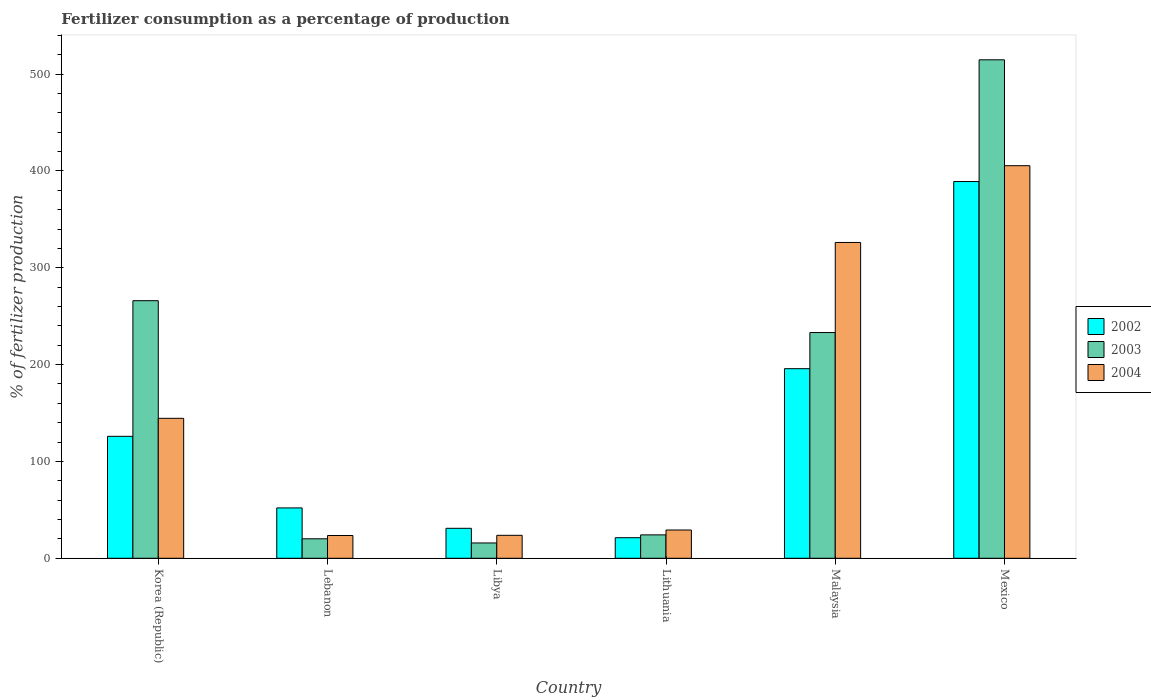How many groups of bars are there?
Provide a succinct answer. 6. Are the number of bars per tick equal to the number of legend labels?
Provide a succinct answer. Yes. Are the number of bars on each tick of the X-axis equal?
Ensure brevity in your answer.  Yes. How many bars are there on the 6th tick from the right?
Offer a terse response. 3. What is the label of the 2nd group of bars from the left?
Make the answer very short. Lebanon. What is the percentage of fertilizers consumed in 2002 in Malaysia?
Keep it short and to the point. 195.8. Across all countries, what is the maximum percentage of fertilizers consumed in 2002?
Provide a succinct answer. 389.08. Across all countries, what is the minimum percentage of fertilizers consumed in 2003?
Your answer should be compact. 15.82. In which country was the percentage of fertilizers consumed in 2004 maximum?
Your answer should be compact. Mexico. In which country was the percentage of fertilizers consumed in 2003 minimum?
Your response must be concise. Libya. What is the total percentage of fertilizers consumed in 2004 in the graph?
Your answer should be compact. 952.53. What is the difference between the percentage of fertilizers consumed in 2004 in Libya and that in Mexico?
Offer a terse response. -381.73. What is the difference between the percentage of fertilizers consumed in 2002 in Lebanon and the percentage of fertilizers consumed in 2003 in Lithuania?
Your answer should be very brief. 27.84. What is the average percentage of fertilizers consumed in 2004 per country?
Offer a very short reply. 158.75. What is the difference between the percentage of fertilizers consumed of/in 2003 and percentage of fertilizers consumed of/in 2004 in Korea (Republic)?
Keep it short and to the point. 121.49. In how many countries, is the percentage of fertilizers consumed in 2004 greater than 80 %?
Keep it short and to the point. 3. What is the ratio of the percentage of fertilizers consumed in 2002 in Libya to that in Mexico?
Your answer should be compact. 0.08. Is the percentage of fertilizers consumed in 2004 in Lebanon less than that in Lithuania?
Your answer should be compact. Yes. What is the difference between the highest and the second highest percentage of fertilizers consumed in 2002?
Keep it short and to the point. -69.85. What is the difference between the highest and the lowest percentage of fertilizers consumed in 2004?
Offer a terse response. 381.93. In how many countries, is the percentage of fertilizers consumed in 2003 greater than the average percentage of fertilizers consumed in 2003 taken over all countries?
Your answer should be very brief. 3. Is the sum of the percentage of fertilizers consumed in 2003 in Libya and Lithuania greater than the maximum percentage of fertilizers consumed in 2004 across all countries?
Keep it short and to the point. No. What does the 3rd bar from the right in Lebanon represents?
Provide a succinct answer. 2002. How many bars are there?
Keep it short and to the point. 18. Are all the bars in the graph horizontal?
Your response must be concise. No. What is the difference between two consecutive major ticks on the Y-axis?
Ensure brevity in your answer.  100. Are the values on the major ticks of Y-axis written in scientific E-notation?
Your response must be concise. No. Does the graph contain any zero values?
Your answer should be compact. No. Does the graph contain grids?
Provide a succinct answer. No. How many legend labels are there?
Your response must be concise. 3. What is the title of the graph?
Make the answer very short. Fertilizer consumption as a percentage of production. Does "1970" appear as one of the legend labels in the graph?
Your answer should be very brief. No. What is the label or title of the X-axis?
Ensure brevity in your answer.  Country. What is the label or title of the Y-axis?
Your response must be concise. % of fertilizer production. What is the % of fertilizer production of 2002 in Korea (Republic)?
Make the answer very short. 125.95. What is the % of fertilizer production of 2003 in Korea (Republic)?
Offer a very short reply. 266.02. What is the % of fertilizer production in 2004 in Korea (Republic)?
Your response must be concise. 144.54. What is the % of fertilizer production in 2003 in Lebanon?
Give a very brief answer. 20.12. What is the % of fertilizer production of 2004 in Lebanon?
Provide a short and direct response. 23.51. What is the % of fertilizer production in 2002 in Libya?
Make the answer very short. 30.95. What is the % of fertilizer production in 2003 in Libya?
Provide a succinct answer. 15.82. What is the % of fertilizer production in 2004 in Libya?
Give a very brief answer. 23.71. What is the % of fertilizer production in 2002 in Lithuania?
Provide a short and direct response. 21.23. What is the % of fertilizer production of 2003 in Lithuania?
Your response must be concise. 24.16. What is the % of fertilizer production of 2004 in Lithuania?
Your answer should be very brief. 29.18. What is the % of fertilizer production in 2002 in Malaysia?
Give a very brief answer. 195.8. What is the % of fertilizer production in 2003 in Malaysia?
Provide a succinct answer. 233.12. What is the % of fertilizer production in 2004 in Malaysia?
Keep it short and to the point. 326.16. What is the % of fertilizer production in 2002 in Mexico?
Keep it short and to the point. 389.08. What is the % of fertilizer production in 2003 in Mexico?
Keep it short and to the point. 514.81. What is the % of fertilizer production in 2004 in Mexico?
Your response must be concise. 405.44. Across all countries, what is the maximum % of fertilizer production in 2002?
Make the answer very short. 389.08. Across all countries, what is the maximum % of fertilizer production of 2003?
Provide a succinct answer. 514.81. Across all countries, what is the maximum % of fertilizer production of 2004?
Keep it short and to the point. 405.44. Across all countries, what is the minimum % of fertilizer production of 2002?
Provide a succinct answer. 21.23. Across all countries, what is the minimum % of fertilizer production of 2003?
Make the answer very short. 15.82. Across all countries, what is the minimum % of fertilizer production in 2004?
Provide a short and direct response. 23.51. What is the total % of fertilizer production in 2002 in the graph?
Make the answer very short. 815.02. What is the total % of fertilizer production in 2003 in the graph?
Make the answer very short. 1074.04. What is the total % of fertilizer production in 2004 in the graph?
Offer a very short reply. 952.53. What is the difference between the % of fertilizer production in 2002 in Korea (Republic) and that in Lebanon?
Ensure brevity in your answer.  73.95. What is the difference between the % of fertilizer production of 2003 in Korea (Republic) and that in Lebanon?
Your answer should be very brief. 245.91. What is the difference between the % of fertilizer production of 2004 in Korea (Republic) and that in Lebanon?
Your answer should be compact. 121.03. What is the difference between the % of fertilizer production of 2002 in Korea (Republic) and that in Libya?
Offer a very short reply. 95. What is the difference between the % of fertilizer production of 2003 in Korea (Republic) and that in Libya?
Give a very brief answer. 250.21. What is the difference between the % of fertilizer production in 2004 in Korea (Republic) and that in Libya?
Your answer should be very brief. 120.83. What is the difference between the % of fertilizer production in 2002 in Korea (Republic) and that in Lithuania?
Ensure brevity in your answer.  104.72. What is the difference between the % of fertilizer production in 2003 in Korea (Republic) and that in Lithuania?
Give a very brief answer. 241.86. What is the difference between the % of fertilizer production in 2004 in Korea (Republic) and that in Lithuania?
Provide a succinct answer. 115.36. What is the difference between the % of fertilizer production in 2002 in Korea (Republic) and that in Malaysia?
Offer a very short reply. -69.85. What is the difference between the % of fertilizer production of 2003 in Korea (Republic) and that in Malaysia?
Ensure brevity in your answer.  32.9. What is the difference between the % of fertilizer production of 2004 in Korea (Republic) and that in Malaysia?
Keep it short and to the point. -181.62. What is the difference between the % of fertilizer production of 2002 in Korea (Republic) and that in Mexico?
Keep it short and to the point. -263.13. What is the difference between the % of fertilizer production of 2003 in Korea (Republic) and that in Mexico?
Make the answer very short. -248.78. What is the difference between the % of fertilizer production in 2004 in Korea (Republic) and that in Mexico?
Offer a very short reply. -260.9. What is the difference between the % of fertilizer production in 2002 in Lebanon and that in Libya?
Your answer should be compact. 21.05. What is the difference between the % of fertilizer production of 2003 in Lebanon and that in Libya?
Offer a terse response. 4.3. What is the difference between the % of fertilizer production in 2004 in Lebanon and that in Libya?
Offer a terse response. -0.2. What is the difference between the % of fertilizer production in 2002 in Lebanon and that in Lithuania?
Offer a very short reply. 30.77. What is the difference between the % of fertilizer production in 2003 in Lebanon and that in Lithuania?
Provide a succinct answer. -4.05. What is the difference between the % of fertilizer production in 2004 in Lebanon and that in Lithuania?
Offer a very short reply. -5.67. What is the difference between the % of fertilizer production of 2002 in Lebanon and that in Malaysia?
Offer a terse response. -143.8. What is the difference between the % of fertilizer production of 2003 in Lebanon and that in Malaysia?
Make the answer very short. -213. What is the difference between the % of fertilizer production in 2004 in Lebanon and that in Malaysia?
Provide a succinct answer. -302.65. What is the difference between the % of fertilizer production in 2002 in Lebanon and that in Mexico?
Offer a terse response. -337.08. What is the difference between the % of fertilizer production of 2003 in Lebanon and that in Mexico?
Keep it short and to the point. -494.69. What is the difference between the % of fertilizer production in 2004 in Lebanon and that in Mexico?
Offer a terse response. -381.93. What is the difference between the % of fertilizer production of 2002 in Libya and that in Lithuania?
Offer a very short reply. 9.72. What is the difference between the % of fertilizer production in 2003 in Libya and that in Lithuania?
Your answer should be very brief. -8.35. What is the difference between the % of fertilizer production in 2004 in Libya and that in Lithuania?
Give a very brief answer. -5.48. What is the difference between the % of fertilizer production in 2002 in Libya and that in Malaysia?
Your response must be concise. -164.85. What is the difference between the % of fertilizer production in 2003 in Libya and that in Malaysia?
Ensure brevity in your answer.  -217.3. What is the difference between the % of fertilizer production of 2004 in Libya and that in Malaysia?
Ensure brevity in your answer.  -302.45. What is the difference between the % of fertilizer production of 2002 in Libya and that in Mexico?
Ensure brevity in your answer.  -358.13. What is the difference between the % of fertilizer production of 2003 in Libya and that in Mexico?
Your answer should be compact. -498.99. What is the difference between the % of fertilizer production in 2004 in Libya and that in Mexico?
Your response must be concise. -381.73. What is the difference between the % of fertilizer production of 2002 in Lithuania and that in Malaysia?
Keep it short and to the point. -174.57. What is the difference between the % of fertilizer production of 2003 in Lithuania and that in Malaysia?
Your answer should be very brief. -208.96. What is the difference between the % of fertilizer production in 2004 in Lithuania and that in Malaysia?
Your answer should be compact. -296.98. What is the difference between the % of fertilizer production in 2002 in Lithuania and that in Mexico?
Offer a very short reply. -367.85. What is the difference between the % of fertilizer production in 2003 in Lithuania and that in Mexico?
Keep it short and to the point. -490.64. What is the difference between the % of fertilizer production of 2004 in Lithuania and that in Mexico?
Provide a short and direct response. -376.26. What is the difference between the % of fertilizer production in 2002 in Malaysia and that in Mexico?
Ensure brevity in your answer.  -193.28. What is the difference between the % of fertilizer production in 2003 in Malaysia and that in Mexico?
Make the answer very short. -281.69. What is the difference between the % of fertilizer production of 2004 in Malaysia and that in Mexico?
Provide a short and direct response. -79.28. What is the difference between the % of fertilizer production of 2002 in Korea (Republic) and the % of fertilizer production of 2003 in Lebanon?
Provide a succinct answer. 105.84. What is the difference between the % of fertilizer production in 2002 in Korea (Republic) and the % of fertilizer production in 2004 in Lebanon?
Offer a terse response. 102.44. What is the difference between the % of fertilizer production in 2003 in Korea (Republic) and the % of fertilizer production in 2004 in Lebanon?
Provide a succinct answer. 242.52. What is the difference between the % of fertilizer production of 2002 in Korea (Republic) and the % of fertilizer production of 2003 in Libya?
Provide a succinct answer. 110.13. What is the difference between the % of fertilizer production in 2002 in Korea (Republic) and the % of fertilizer production in 2004 in Libya?
Your answer should be compact. 102.25. What is the difference between the % of fertilizer production of 2003 in Korea (Republic) and the % of fertilizer production of 2004 in Libya?
Keep it short and to the point. 242.32. What is the difference between the % of fertilizer production of 2002 in Korea (Republic) and the % of fertilizer production of 2003 in Lithuania?
Your response must be concise. 101.79. What is the difference between the % of fertilizer production of 2002 in Korea (Republic) and the % of fertilizer production of 2004 in Lithuania?
Offer a terse response. 96.77. What is the difference between the % of fertilizer production in 2003 in Korea (Republic) and the % of fertilizer production in 2004 in Lithuania?
Give a very brief answer. 236.84. What is the difference between the % of fertilizer production of 2002 in Korea (Republic) and the % of fertilizer production of 2003 in Malaysia?
Provide a short and direct response. -107.17. What is the difference between the % of fertilizer production of 2002 in Korea (Republic) and the % of fertilizer production of 2004 in Malaysia?
Make the answer very short. -200.21. What is the difference between the % of fertilizer production in 2003 in Korea (Republic) and the % of fertilizer production in 2004 in Malaysia?
Your response must be concise. -60.14. What is the difference between the % of fertilizer production of 2002 in Korea (Republic) and the % of fertilizer production of 2003 in Mexico?
Your answer should be compact. -388.85. What is the difference between the % of fertilizer production of 2002 in Korea (Republic) and the % of fertilizer production of 2004 in Mexico?
Offer a terse response. -279.49. What is the difference between the % of fertilizer production in 2003 in Korea (Republic) and the % of fertilizer production in 2004 in Mexico?
Offer a terse response. -139.42. What is the difference between the % of fertilizer production in 2002 in Lebanon and the % of fertilizer production in 2003 in Libya?
Your answer should be very brief. 36.18. What is the difference between the % of fertilizer production of 2002 in Lebanon and the % of fertilizer production of 2004 in Libya?
Offer a terse response. 28.29. What is the difference between the % of fertilizer production of 2003 in Lebanon and the % of fertilizer production of 2004 in Libya?
Offer a very short reply. -3.59. What is the difference between the % of fertilizer production of 2002 in Lebanon and the % of fertilizer production of 2003 in Lithuania?
Your answer should be very brief. 27.84. What is the difference between the % of fertilizer production in 2002 in Lebanon and the % of fertilizer production in 2004 in Lithuania?
Offer a very short reply. 22.82. What is the difference between the % of fertilizer production in 2003 in Lebanon and the % of fertilizer production in 2004 in Lithuania?
Provide a short and direct response. -9.07. What is the difference between the % of fertilizer production of 2002 in Lebanon and the % of fertilizer production of 2003 in Malaysia?
Provide a succinct answer. -181.12. What is the difference between the % of fertilizer production in 2002 in Lebanon and the % of fertilizer production in 2004 in Malaysia?
Offer a very short reply. -274.16. What is the difference between the % of fertilizer production of 2003 in Lebanon and the % of fertilizer production of 2004 in Malaysia?
Offer a very short reply. -306.04. What is the difference between the % of fertilizer production of 2002 in Lebanon and the % of fertilizer production of 2003 in Mexico?
Provide a succinct answer. -462.81. What is the difference between the % of fertilizer production in 2002 in Lebanon and the % of fertilizer production in 2004 in Mexico?
Your answer should be very brief. -353.44. What is the difference between the % of fertilizer production in 2003 in Lebanon and the % of fertilizer production in 2004 in Mexico?
Your response must be concise. -385.32. What is the difference between the % of fertilizer production in 2002 in Libya and the % of fertilizer production in 2003 in Lithuania?
Provide a succinct answer. 6.79. What is the difference between the % of fertilizer production in 2002 in Libya and the % of fertilizer production in 2004 in Lithuania?
Ensure brevity in your answer.  1.77. What is the difference between the % of fertilizer production in 2003 in Libya and the % of fertilizer production in 2004 in Lithuania?
Your answer should be very brief. -13.37. What is the difference between the % of fertilizer production of 2002 in Libya and the % of fertilizer production of 2003 in Malaysia?
Offer a very short reply. -202.17. What is the difference between the % of fertilizer production of 2002 in Libya and the % of fertilizer production of 2004 in Malaysia?
Your response must be concise. -295.2. What is the difference between the % of fertilizer production of 2003 in Libya and the % of fertilizer production of 2004 in Malaysia?
Make the answer very short. -310.34. What is the difference between the % of fertilizer production of 2002 in Libya and the % of fertilizer production of 2003 in Mexico?
Provide a short and direct response. -483.85. What is the difference between the % of fertilizer production of 2002 in Libya and the % of fertilizer production of 2004 in Mexico?
Give a very brief answer. -374.48. What is the difference between the % of fertilizer production in 2003 in Libya and the % of fertilizer production in 2004 in Mexico?
Give a very brief answer. -389.62. What is the difference between the % of fertilizer production of 2002 in Lithuania and the % of fertilizer production of 2003 in Malaysia?
Your answer should be compact. -211.89. What is the difference between the % of fertilizer production in 2002 in Lithuania and the % of fertilizer production in 2004 in Malaysia?
Give a very brief answer. -304.93. What is the difference between the % of fertilizer production of 2003 in Lithuania and the % of fertilizer production of 2004 in Malaysia?
Keep it short and to the point. -302. What is the difference between the % of fertilizer production in 2002 in Lithuania and the % of fertilizer production in 2003 in Mexico?
Your answer should be compact. -493.57. What is the difference between the % of fertilizer production in 2002 in Lithuania and the % of fertilizer production in 2004 in Mexico?
Your response must be concise. -384.21. What is the difference between the % of fertilizer production in 2003 in Lithuania and the % of fertilizer production in 2004 in Mexico?
Your answer should be very brief. -381.28. What is the difference between the % of fertilizer production of 2002 in Malaysia and the % of fertilizer production of 2003 in Mexico?
Give a very brief answer. -319. What is the difference between the % of fertilizer production of 2002 in Malaysia and the % of fertilizer production of 2004 in Mexico?
Keep it short and to the point. -209.64. What is the difference between the % of fertilizer production of 2003 in Malaysia and the % of fertilizer production of 2004 in Mexico?
Your answer should be compact. -172.32. What is the average % of fertilizer production of 2002 per country?
Ensure brevity in your answer.  135.84. What is the average % of fertilizer production in 2003 per country?
Ensure brevity in your answer.  179.01. What is the average % of fertilizer production in 2004 per country?
Provide a short and direct response. 158.75. What is the difference between the % of fertilizer production in 2002 and % of fertilizer production in 2003 in Korea (Republic)?
Make the answer very short. -140.07. What is the difference between the % of fertilizer production of 2002 and % of fertilizer production of 2004 in Korea (Republic)?
Your answer should be compact. -18.59. What is the difference between the % of fertilizer production of 2003 and % of fertilizer production of 2004 in Korea (Republic)?
Offer a very short reply. 121.49. What is the difference between the % of fertilizer production of 2002 and % of fertilizer production of 2003 in Lebanon?
Offer a terse response. 31.88. What is the difference between the % of fertilizer production of 2002 and % of fertilizer production of 2004 in Lebanon?
Provide a succinct answer. 28.49. What is the difference between the % of fertilizer production of 2003 and % of fertilizer production of 2004 in Lebanon?
Offer a very short reply. -3.39. What is the difference between the % of fertilizer production in 2002 and % of fertilizer production in 2003 in Libya?
Give a very brief answer. 15.14. What is the difference between the % of fertilizer production of 2002 and % of fertilizer production of 2004 in Libya?
Keep it short and to the point. 7.25. What is the difference between the % of fertilizer production of 2003 and % of fertilizer production of 2004 in Libya?
Provide a short and direct response. -7.89. What is the difference between the % of fertilizer production of 2002 and % of fertilizer production of 2003 in Lithuania?
Ensure brevity in your answer.  -2.93. What is the difference between the % of fertilizer production in 2002 and % of fertilizer production in 2004 in Lithuania?
Your response must be concise. -7.95. What is the difference between the % of fertilizer production in 2003 and % of fertilizer production in 2004 in Lithuania?
Keep it short and to the point. -5.02. What is the difference between the % of fertilizer production of 2002 and % of fertilizer production of 2003 in Malaysia?
Keep it short and to the point. -37.32. What is the difference between the % of fertilizer production in 2002 and % of fertilizer production in 2004 in Malaysia?
Make the answer very short. -130.36. What is the difference between the % of fertilizer production in 2003 and % of fertilizer production in 2004 in Malaysia?
Provide a short and direct response. -93.04. What is the difference between the % of fertilizer production of 2002 and % of fertilizer production of 2003 in Mexico?
Make the answer very short. -125.73. What is the difference between the % of fertilizer production in 2002 and % of fertilizer production in 2004 in Mexico?
Give a very brief answer. -16.36. What is the difference between the % of fertilizer production in 2003 and % of fertilizer production in 2004 in Mexico?
Your answer should be very brief. 109.37. What is the ratio of the % of fertilizer production of 2002 in Korea (Republic) to that in Lebanon?
Keep it short and to the point. 2.42. What is the ratio of the % of fertilizer production of 2003 in Korea (Republic) to that in Lebanon?
Keep it short and to the point. 13.22. What is the ratio of the % of fertilizer production of 2004 in Korea (Republic) to that in Lebanon?
Give a very brief answer. 6.15. What is the ratio of the % of fertilizer production of 2002 in Korea (Republic) to that in Libya?
Ensure brevity in your answer.  4.07. What is the ratio of the % of fertilizer production of 2003 in Korea (Republic) to that in Libya?
Ensure brevity in your answer.  16.82. What is the ratio of the % of fertilizer production in 2004 in Korea (Republic) to that in Libya?
Your answer should be very brief. 6.1. What is the ratio of the % of fertilizer production of 2002 in Korea (Republic) to that in Lithuania?
Give a very brief answer. 5.93. What is the ratio of the % of fertilizer production of 2003 in Korea (Republic) to that in Lithuania?
Your answer should be compact. 11.01. What is the ratio of the % of fertilizer production in 2004 in Korea (Republic) to that in Lithuania?
Provide a short and direct response. 4.95. What is the ratio of the % of fertilizer production of 2002 in Korea (Republic) to that in Malaysia?
Your answer should be compact. 0.64. What is the ratio of the % of fertilizer production of 2003 in Korea (Republic) to that in Malaysia?
Provide a succinct answer. 1.14. What is the ratio of the % of fertilizer production in 2004 in Korea (Republic) to that in Malaysia?
Your response must be concise. 0.44. What is the ratio of the % of fertilizer production of 2002 in Korea (Republic) to that in Mexico?
Provide a short and direct response. 0.32. What is the ratio of the % of fertilizer production in 2003 in Korea (Republic) to that in Mexico?
Keep it short and to the point. 0.52. What is the ratio of the % of fertilizer production of 2004 in Korea (Republic) to that in Mexico?
Give a very brief answer. 0.36. What is the ratio of the % of fertilizer production of 2002 in Lebanon to that in Libya?
Your answer should be compact. 1.68. What is the ratio of the % of fertilizer production in 2003 in Lebanon to that in Libya?
Your answer should be compact. 1.27. What is the ratio of the % of fertilizer production in 2004 in Lebanon to that in Libya?
Offer a very short reply. 0.99. What is the ratio of the % of fertilizer production in 2002 in Lebanon to that in Lithuania?
Give a very brief answer. 2.45. What is the ratio of the % of fertilizer production of 2003 in Lebanon to that in Lithuania?
Your answer should be compact. 0.83. What is the ratio of the % of fertilizer production in 2004 in Lebanon to that in Lithuania?
Your answer should be compact. 0.81. What is the ratio of the % of fertilizer production of 2002 in Lebanon to that in Malaysia?
Your response must be concise. 0.27. What is the ratio of the % of fertilizer production of 2003 in Lebanon to that in Malaysia?
Your answer should be compact. 0.09. What is the ratio of the % of fertilizer production of 2004 in Lebanon to that in Malaysia?
Keep it short and to the point. 0.07. What is the ratio of the % of fertilizer production in 2002 in Lebanon to that in Mexico?
Provide a succinct answer. 0.13. What is the ratio of the % of fertilizer production of 2003 in Lebanon to that in Mexico?
Give a very brief answer. 0.04. What is the ratio of the % of fertilizer production in 2004 in Lebanon to that in Mexico?
Provide a succinct answer. 0.06. What is the ratio of the % of fertilizer production in 2002 in Libya to that in Lithuania?
Your response must be concise. 1.46. What is the ratio of the % of fertilizer production in 2003 in Libya to that in Lithuania?
Provide a short and direct response. 0.65. What is the ratio of the % of fertilizer production of 2004 in Libya to that in Lithuania?
Your answer should be very brief. 0.81. What is the ratio of the % of fertilizer production of 2002 in Libya to that in Malaysia?
Your answer should be compact. 0.16. What is the ratio of the % of fertilizer production in 2003 in Libya to that in Malaysia?
Keep it short and to the point. 0.07. What is the ratio of the % of fertilizer production in 2004 in Libya to that in Malaysia?
Offer a very short reply. 0.07. What is the ratio of the % of fertilizer production of 2002 in Libya to that in Mexico?
Make the answer very short. 0.08. What is the ratio of the % of fertilizer production of 2003 in Libya to that in Mexico?
Your answer should be very brief. 0.03. What is the ratio of the % of fertilizer production in 2004 in Libya to that in Mexico?
Your response must be concise. 0.06. What is the ratio of the % of fertilizer production of 2002 in Lithuania to that in Malaysia?
Keep it short and to the point. 0.11. What is the ratio of the % of fertilizer production in 2003 in Lithuania to that in Malaysia?
Offer a terse response. 0.1. What is the ratio of the % of fertilizer production in 2004 in Lithuania to that in Malaysia?
Provide a succinct answer. 0.09. What is the ratio of the % of fertilizer production in 2002 in Lithuania to that in Mexico?
Offer a terse response. 0.05. What is the ratio of the % of fertilizer production of 2003 in Lithuania to that in Mexico?
Offer a terse response. 0.05. What is the ratio of the % of fertilizer production of 2004 in Lithuania to that in Mexico?
Your answer should be very brief. 0.07. What is the ratio of the % of fertilizer production of 2002 in Malaysia to that in Mexico?
Give a very brief answer. 0.5. What is the ratio of the % of fertilizer production of 2003 in Malaysia to that in Mexico?
Make the answer very short. 0.45. What is the ratio of the % of fertilizer production of 2004 in Malaysia to that in Mexico?
Ensure brevity in your answer.  0.8. What is the difference between the highest and the second highest % of fertilizer production in 2002?
Your answer should be very brief. 193.28. What is the difference between the highest and the second highest % of fertilizer production of 2003?
Offer a terse response. 248.78. What is the difference between the highest and the second highest % of fertilizer production in 2004?
Your answer should be compact. 79.28. What is the difference between the highest and the lowest % of fertilizer production in 2002?
Offer a terse response. 367.85. What is the difference between the highest and the lowest % of fertilizer production in 2003?
Offer a terse response. 498.99. What is the difference between the highest and the lowest % of fertilizer production of 2004?
Give a very brief answer. 381.93. 